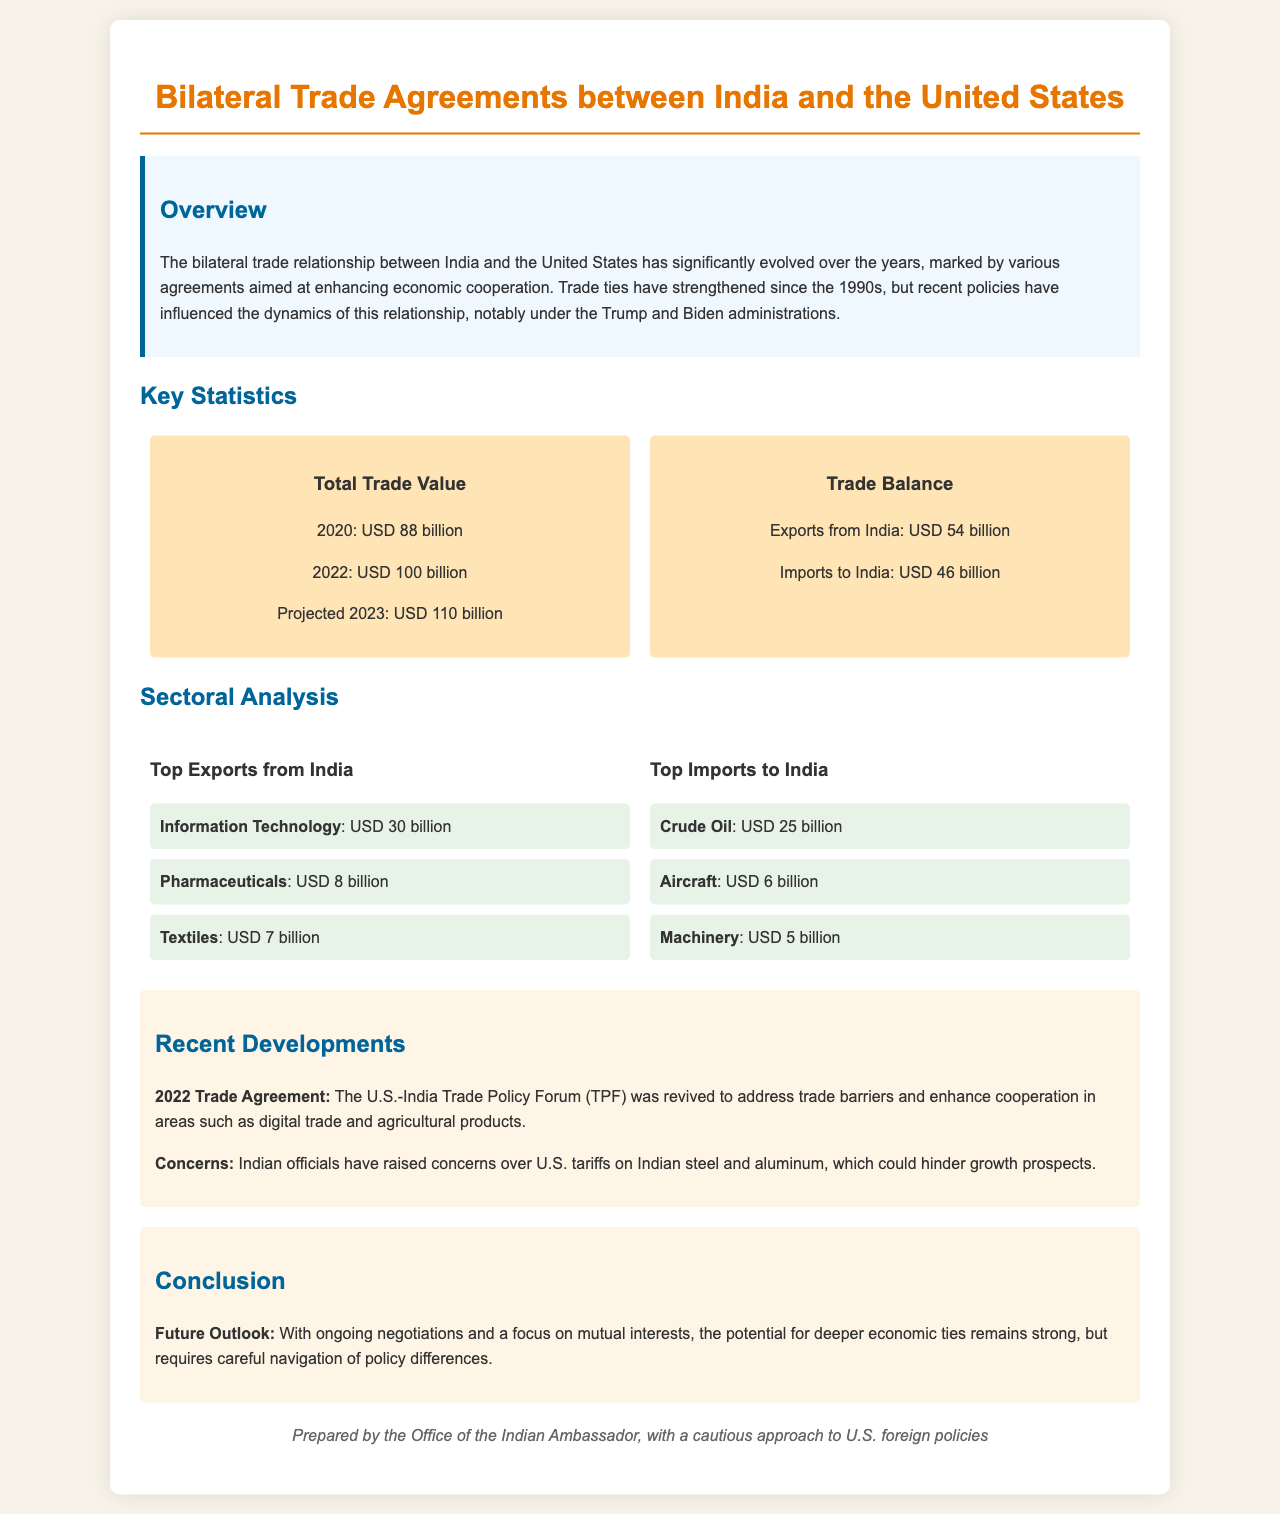what is the total trade value in 2022? The total trade value in 2022 is explicitly stated in the document.
Answer: USD 100 billion what are the top exports from India? The document lists the top exports from India.
Answer: Information Technology, Pharmaceuticals, Textiles how much is the trade balance? The trade balance is the difference between exports and imports as mentioned in the report.
Answer: USD 8 billion what was a concern raised by Indian officials? The document specifies concerns that Indian officials have regarding U.S. trade policies.
Answer: U.S. tariffs on Indian steel and aluminum what percentage increase is projected for trade value in 2023 compared to 2022? The projected increase in trade value from 2022 to 2023 can be calculated based on the values provided.
Answer: 10 percent what significant trade forum was revived in 2022? The document mentions the name of the trade forum that was revived.
Answer: U.S.-India Trade Policy Forum what is the top import to India? The document specifies the top import to India.
Answer: Crude Oil what has been the trend of trade ties since the 1990s? The document states the general trend observed in trade ties between India and the U.S. since the 1990s.
Answer: Strengthened what is the projected trade value for 2023? The projected trade value for 2023 is the value mentioned in the report.
Answer: USD 110 billion what sector contributed USD 30 billion in exports from India? The report specifies which sector contributed significantly to India's exports.
Answer: Information Technology 